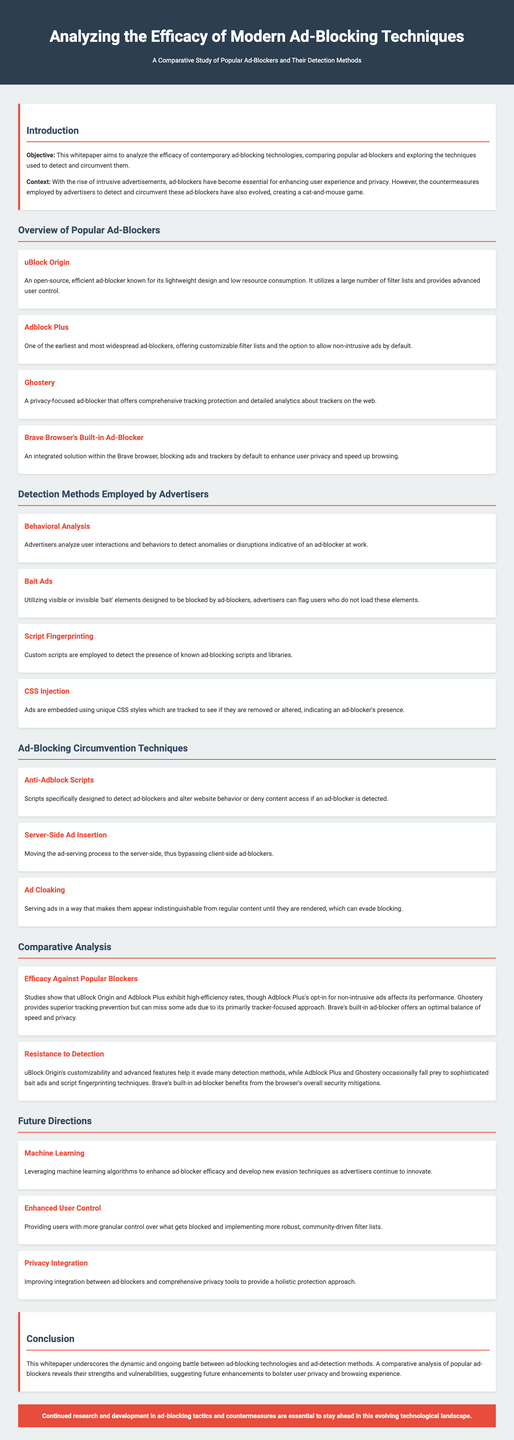What is the objective of the whitepaper? The objective is to analyze the efficacy of contemporary ad-blocking technologies and compare popular ad-blockers while exploring detection techniques.
Answer: Analyze the efficacy of contemporary ad-blocking technologies Name one popular ad-blocker discussed in the document. uBlock Origin is mentioned as one of the popular ad-blockers in the document.
Answer: uBlock Origin What method do advertisers use to detect anomalies indicative of ad-blockers? Behavioral Analysis is noted as a method employed by advertisers to detect anomalies or disruptions in user interactions.
Answer: Behavioral Analysis Which ad-blocker offers customizable filter lists? Adblock Plus is known for providing customizable filter lists.
Answer: Adblock Plus What does the conclusion of the whitepaper emphasize? The conclusion underscores the dynamic battle between ad-blocking technologies and ad-detection methods.
Answer: Dynamic battle What future direction involves algorithms? Machine Learning is identified as a future direction for enhancing ad-blocker efficacy.
Answer: Machine Learning Identify one ad-blocking circumvention technique mentioned. Anti-Adblock Scripts are listed as a circumvention technique employed by advertisers.
Answer: Anti-Adblock Scripts What is a key advantage of Brave's built-in ad-blocker? The built-in ad-blocker in Brave offers an optimal balance of speed and privacy.
Answer: Optimal balance of speed and privacy 